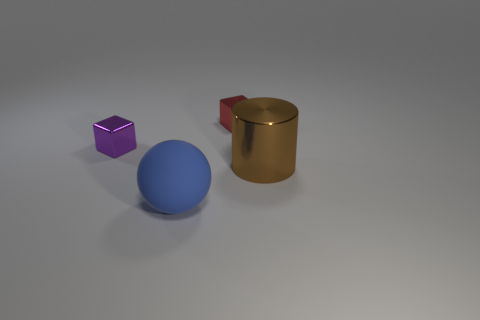There is a thing behind the block in front of the small red object; what size is it?
Give a very brief answer. Small. There is a metal thing that is both on the right side of the purple shiny thing and in front of the small red shiny object; what shape is it?
Provide a short and direct response. Cylinder. What number of cylinders are either large brown shiny objects or small yellow things?
Your response must be concise. 1. Is the number of small red metal cubes left of the matte thing less than the number of big brown cylinders?
Offer a terse response. Yes. There is a object that is both in front of the purple cube and behind the rubber sphere; what color is it?
Provide a succinct answer. Brown. What number of other objects are there of the same shape as the red metallic object?
Your answer should be compact. 1. Are there fewer large shiny cylinders in front of the large metal thing than purple metallic things that are in front of the small purple thing?
Provide a succinct answer. No. Do the red object and the big object on the left side of the big brown metallic cylinder have the same material?
Provide a short and direct response. No. Are there any other things that have the same material as the purple thing?
Provide a short and direct response. Yes. Is the number of small red things greater than the number of small cyan metal things?
Offer a very short reply. Yes. 